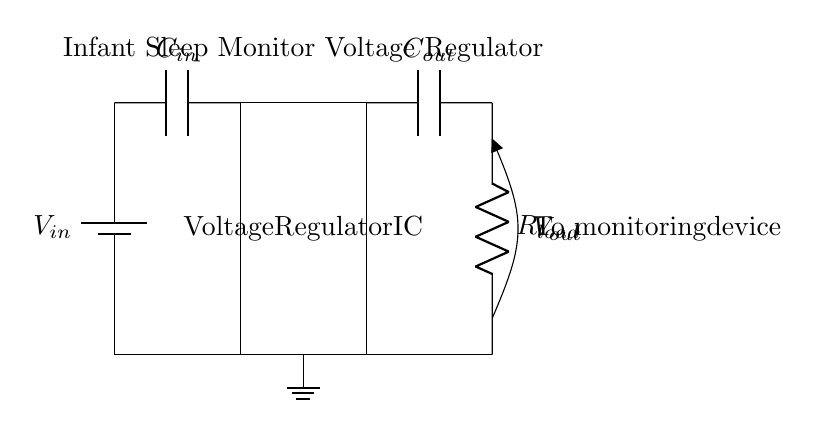What type of circuit is this? This is a voltage regulator circuit, which is designed to maintain a constant output voltage. The components work together to provide stable voltage for the infant sleep monitor.
Answer: voltage regulator What is the purpose of the input capacitor? The input capacitor smooths the voltage supply and provides a stable input to the voltage regulator, reducing voltage fluctuations and ensuring stable input conditions.
Answer: stabilize input What component indicates the output voltage? The open component labeled Vout shows the output voltage of the circuit, providing a connection point for monitoring devices to receive regulated voltage.
Answer: Vout What does Rload represent? Rload is the load resistor that indicates the resistance connected to the output of the voltage regulator, simulating the load that the monitoring device will present.
Answer: load resistor How is the ground connected in this circuit? The ground is connected to the negative terminal of the power supply and provides a common reference point for all voltages in the circuit, ensuring proper operation of the components.
Answer: common ground What is the value of the component Cout? Cout is an output capacitor, which smooths the output voltage by filtering out high-frequency noise, ensuring stable voltage is delivered to the load.
Answer: output capacitor 